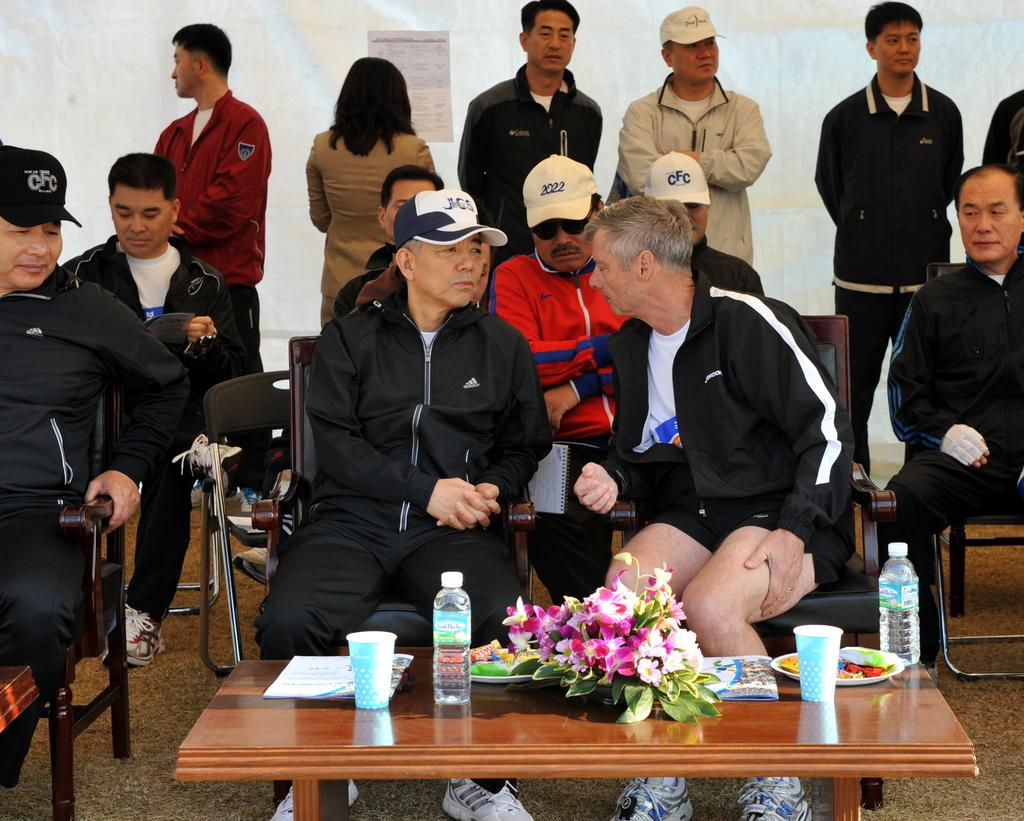What type of objects can be seen in the image related to serving or consuming beverages? There are glasses and bottles in the image. What other items are present in the image that might be used for entertainment or games? There are cards in the image. What can be seen on the plates in the image? There are food items on plates in the image. What decorative elements are present on the table in the image? There are flowers on the table in the image. Can you describe the people in the image? There is a group of people standing and a group of people sitting on chairs in the image. What type of comb is being used by the person in the image? There is no comb present in the image. What town is visible in the background of the image? There is no town visible in the image. 